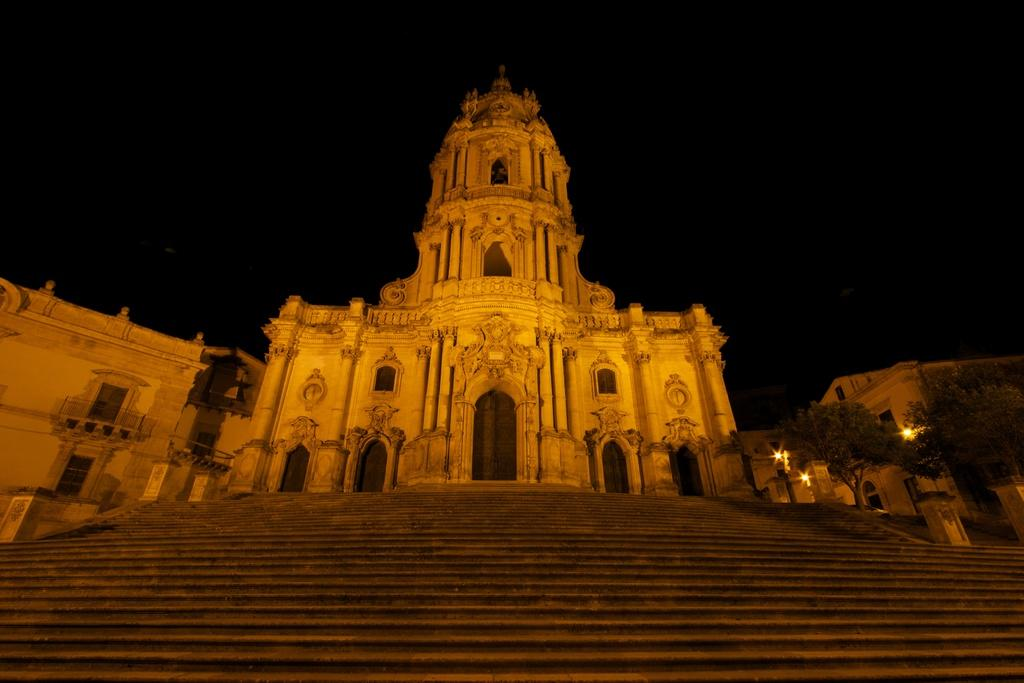What type of structure is present in the image? There is a building in the image. Are there any architectural features visible in the image? Yes, there are steps in the image. What type of vegetation can be seen in the image? There are trees in the image. What can be used for illumination in the image? There are lights in the image. What is visible in the background of the image? The sky is visible in the background of the image. Can you see any pigs swimming in the lake in the image? There is no lake or pigs present in the image. What color is the orange in the image? There is no orange present in the image. 